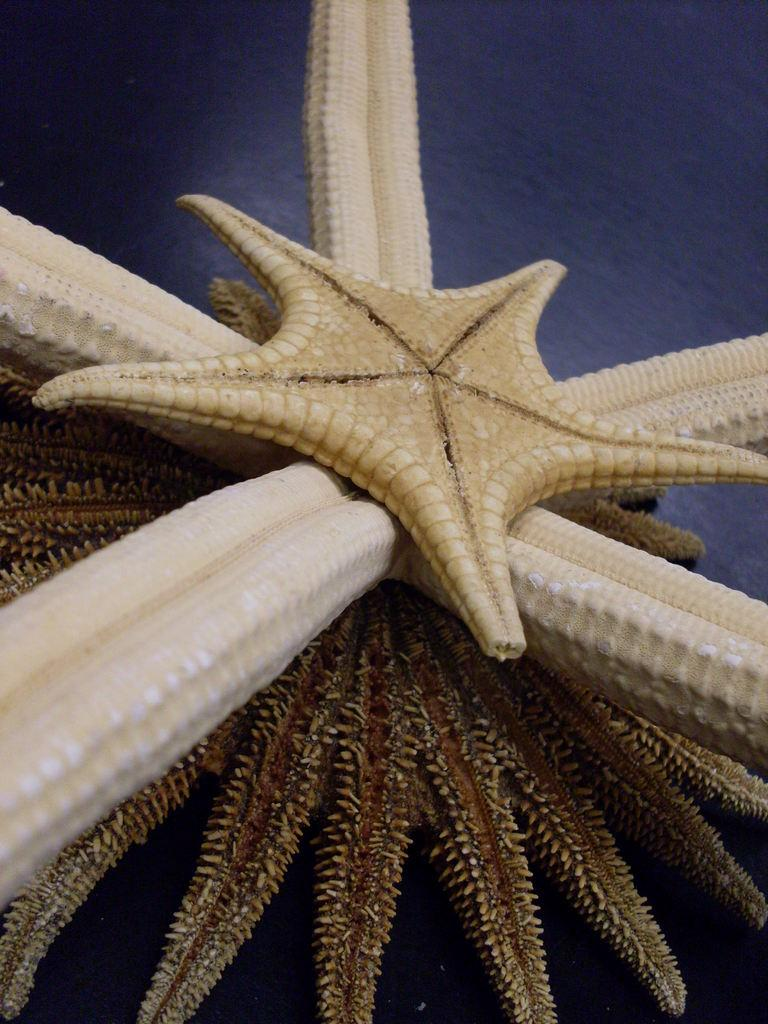What is the main subject of the image? There is a starfish in the image. What color is the background of the image? The background of the image is blue. What is the starfish's tendency to hope for a low tide in the image? There is no indication of the starfish's hopes or tendencies in the image, as it is a static image and does not depict the starfish's thoughts or actions. 